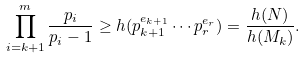<formula> <loc_0><loc_0><loc_500><loc_500>\prod _ { i = k + 1 } ^ { m } \frac { p _ { i } } { p _ { i } - 1 } \geq h ( p _ { k + 1 } ^ { e _ { k + 1 } } \cdots p _ { r } ^ { e _ { r } } ) = \frac { h ( N ) } { h ( M _ { k } ) } .</formula> 